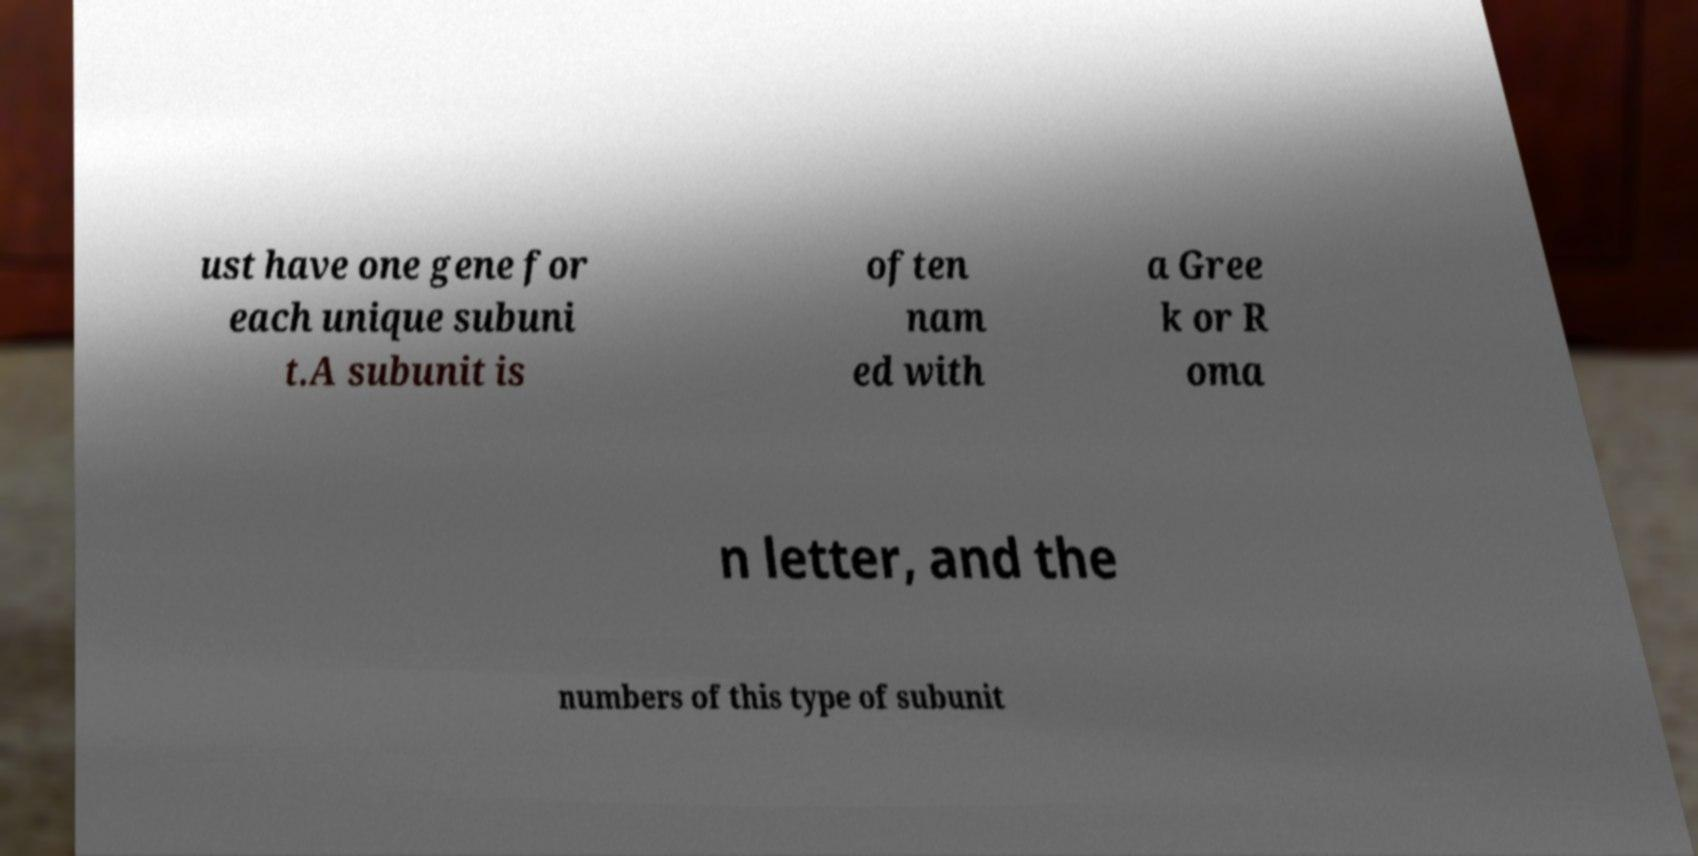What messages or text are displayed in this image? I need them in a readable, typed format. ust have one gene for each unique subuni t.A subunit is often nam ed with a Gree k or R oma n letter, and the numbers of this type of subunit 